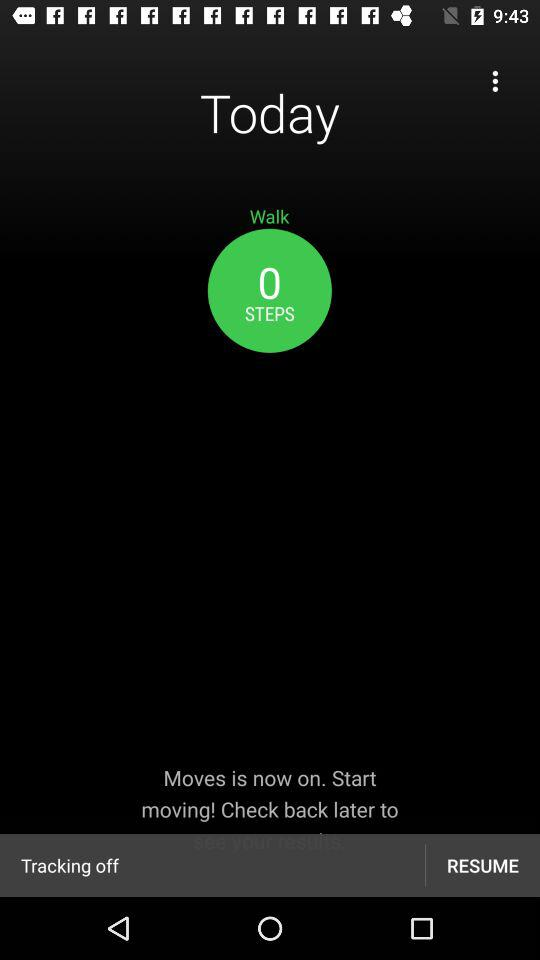How many steps have I taken today?
Answer the question using a single word or phrase. 0 